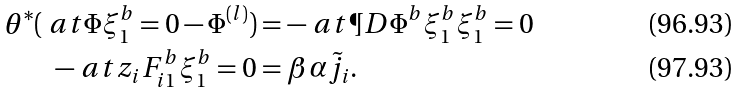Convert formula to latex. <formula><loc_0><loc_0><loc_500><loc_500>\theta ^ { * } ( \ a t { \Phi } { \xi _ { 1 } ^ { b } = 0 } - \Phi ^ { ( l ) } ) & = - \ a t { \P D { \Phi ^ { b } } { \xi _ { 1 } ^ { b } } } { \xi _ { 1 } ^ { b } = 0 } \\ - \ a t { z _ { i } F _ { i 1 } ^ { b } } { \xi _ { 1 } ^ { b } = 0 } & = \beta \alpha \tilde { j } _ { i } .</formula> 